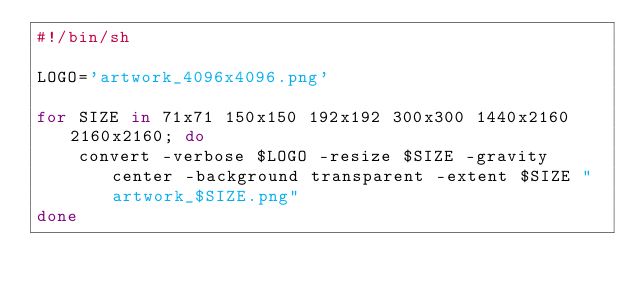<code> <loc_0><loc_0><loc_500><loc_500><_Bash_>#!/bin/sh

LOGO='artwork_4096x4096.png'

for SIZE in 71x71 150x150 192x192 300x300 1440x2160 2160x2160; do
	convert -verbose $LOGO -resize $SIZE -gravity center -background transparent -extent $SIZE "artwork_$SIZE.png"
done
</code> 